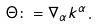<formula> <loc_0><loc_0><loc_500><loc_500>\Theta \colon = \nabla _ { \alpha } k ^ { \alpha } .</formula> 